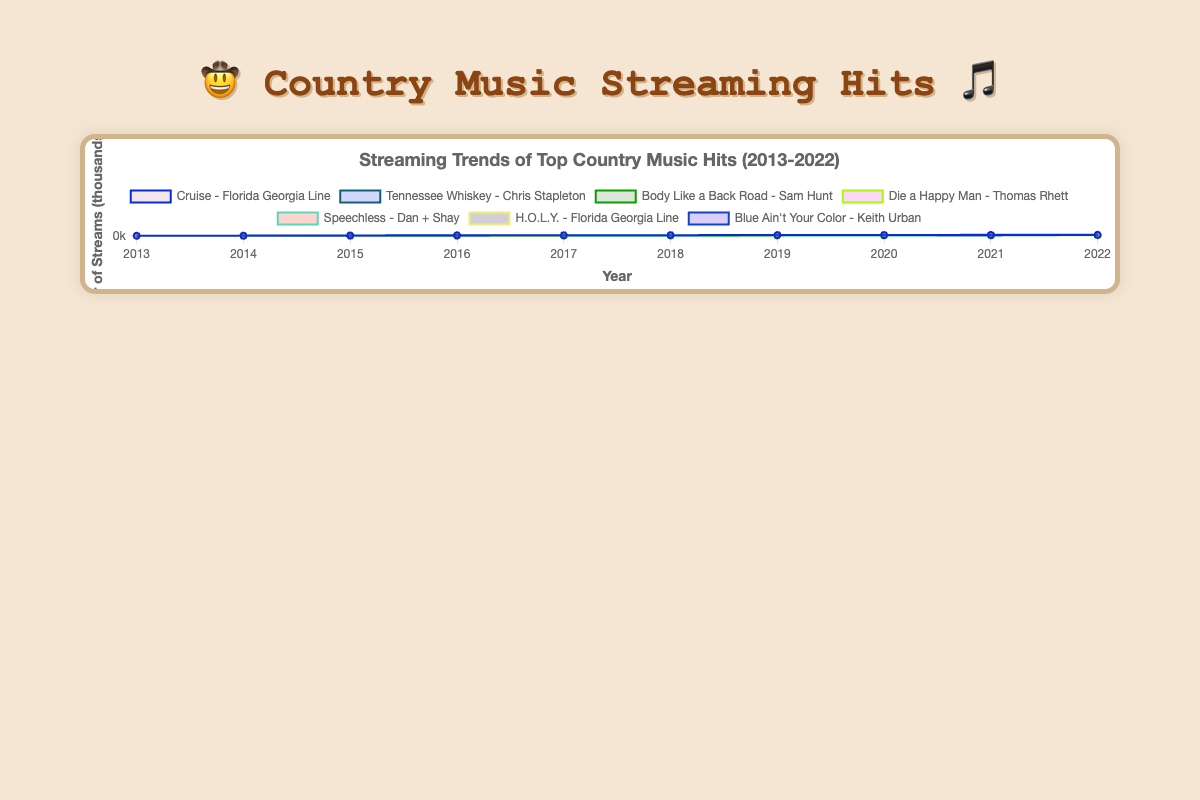What is the title of the chart? The title of the chart is usually placed at the top of the chart. Here, it is stated clearly: "Streaming Trends of Top Country Music Hits (2013-2022)"
Answer: Streaming Trends of Top Country Music Hits (2013-2022) Which song has the most streams in 2022? Look at the streams for 2022, then find the song with the highest value. "Tennessee Whiskey - Chris Stapleton" has 9000 streams, the highest for that year.
Answer: Tennessee Whiskey - Chris Stapleton How many songs started to have streams in 2015? Look at the streams data for 2015. The songs "Body Like a Back Road - Sam Hunt" started to have streams that year. Only one song fits this criterion.
Answer: 1 What is the average streams of "Cruise - Florida Georgia Line" over the decade? Sum the streams from 2013-2022 for "Cruise - Florida Georgia Line" and then divide by 10: (500 + 1500 + 3000 + 4500 + 5000 + 5500 + 6000 + 6500 + 7000 + 7500)/10 = 4690
Answer: 4690 Which song had the steepest increase in streams between 2016 and 2017? Calculate the difference in streams for each song between 2016 and 2017, then identify the largest increase. "Tennessee Whiskey - Chris Stapleton" increased from 3000 to 5000, which is an increase of 2000, the largest among all the songs.
Answer: Tennessee Whiskey - Chris Stapleton Which song has a consistent increase in streams over the entire decade? Check each song's stream data year by year to see if there are no drops. "Cruise - Florida Georgia Line" and "Tennessee Whiskey - Chris Stapleton" both show consistent increases every year.
Answer: Cruise - Florida Georgia Line, Tennessee Whiskey - Chris Stapleton What is the total number of streams for "Body Like a Back Road - Sam Hunt" from 2015 to 2019? Sum the streams from 2015 to 2019: 100 + 1000 + 2500 + 3000 + 3500 = 10100
Answer: 10100 How many data points are displayed for each song on the chart? Each song has one data point per year from 2013 to 2022, so each song has 10 data points.
Answer: 10 Between "Die a Happy Man - Thomas Rhett" and "Blue Ain't Your Color - Keith Urban", which song had a higher number of streams in 2016? Look at the data for 2016. "Die a Happy Man - Thomas Rhett" had 500 streams, while "Blue Ain't Your Color - Keith Urban" also had 500 streams. So, they are equal in 2016.
Answer: They are equal in 2016 How did "Speechless - Dan + Shay" perform in terms of streaming from 2017 to 2019? Look at the streams for "Speechless - Dan + Shay" from 2017 to 2019: For 2017: 0, 2018: 500, 2019: 2000. There was a significant increase in 2018 and 2019.
Answer: Significant increase in 2018 and 2019 